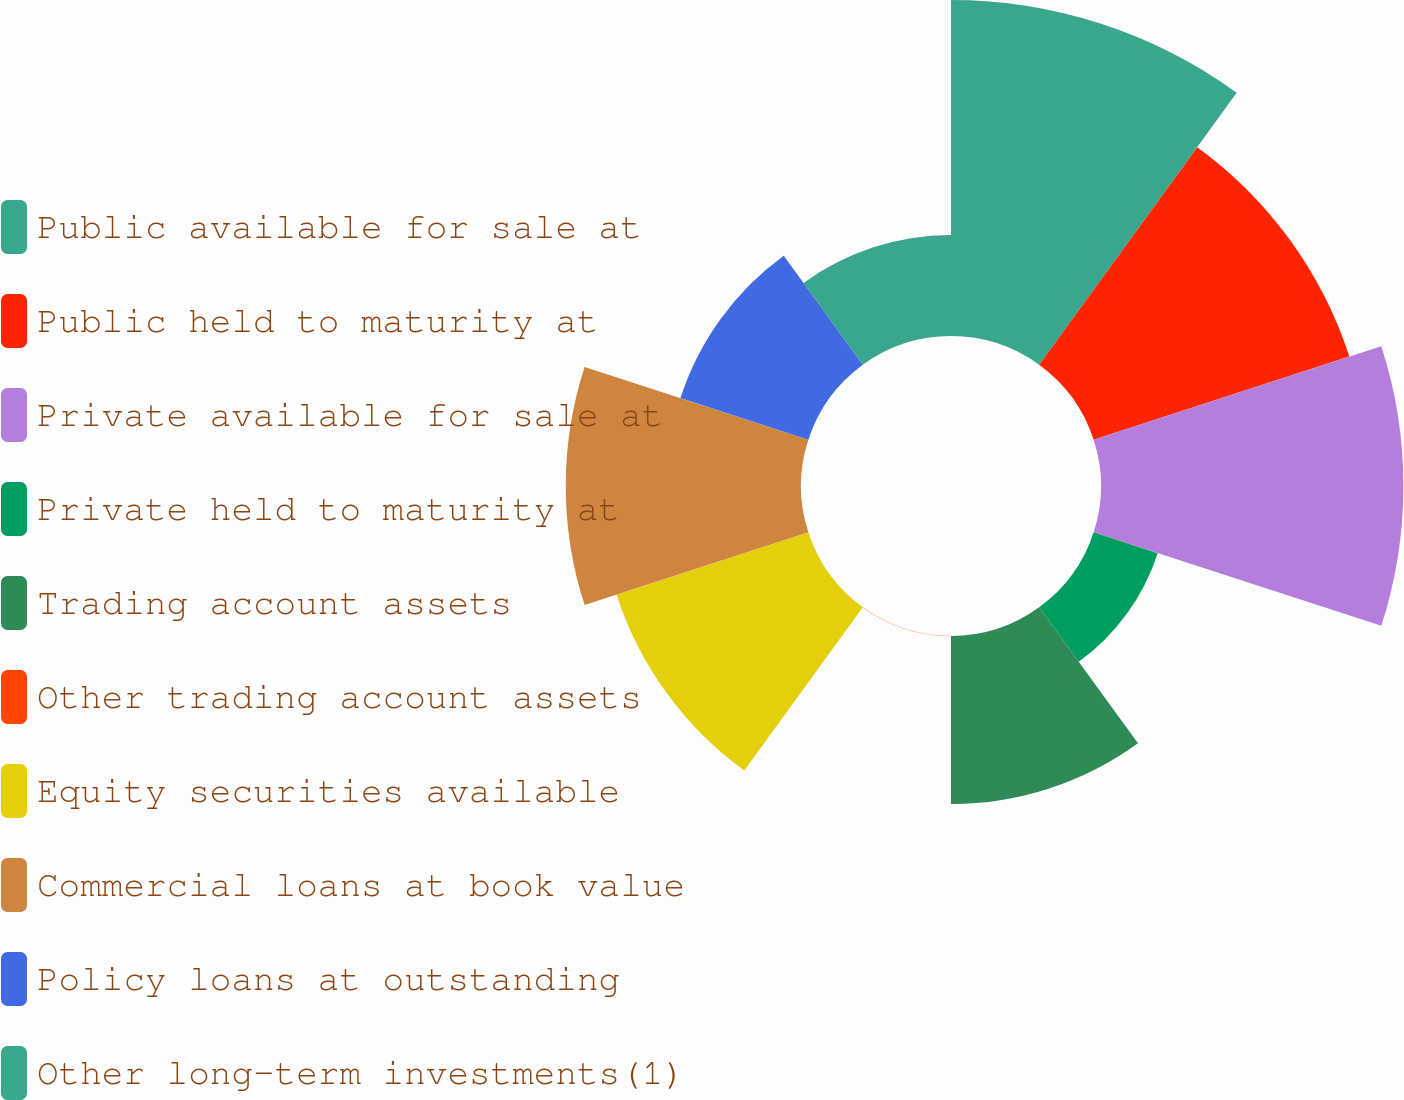<chart> <loc_0><loc_0><loc_500><loc_500><pie_chart><fcel>Public available for sale at<fcel>Public held to maturity at<fcel>Private available for sale at<fcel>Private held to maturity at<fcel>Trading account assets<fcel>Other trading account assets<fcel>Equity securities available<fcel>Commercial loans at book value<fcel>Policy loans at outstanding<fcel>Other long-term investments(1)<nl><fcel>18.51%<fcel>14.81%<fcel>16.66%<fcel>3.71%<fcel>9.26%<fcel>0.01%<fcel>11.11%<fcel>12.96%<fcel>7.41%<fcel>5.56%<nl></chart> 